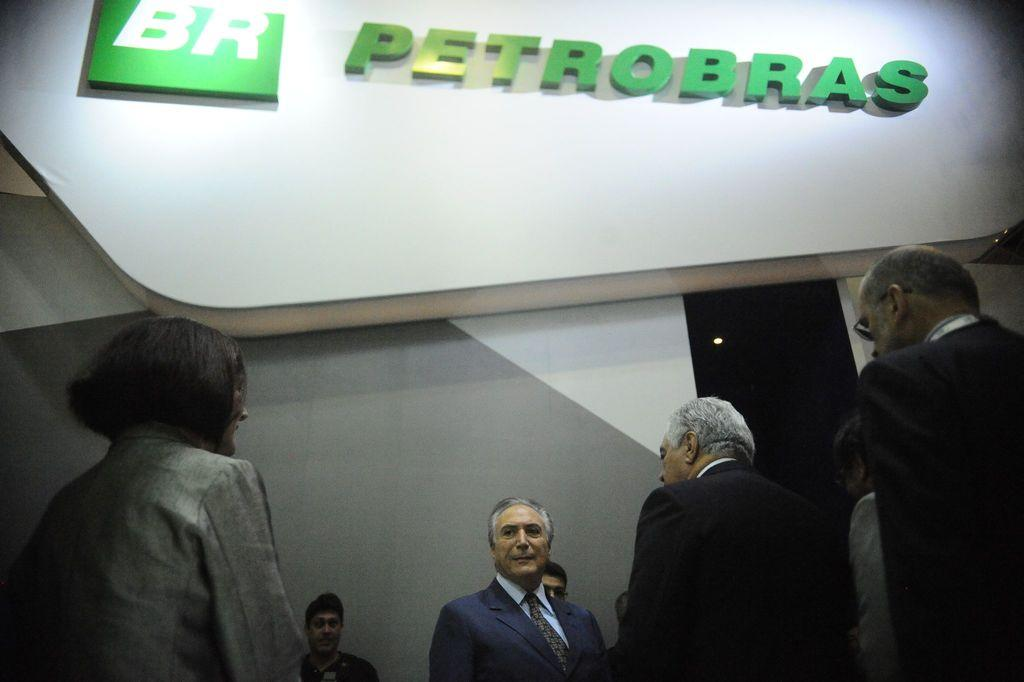How many people are in the image? There is a group of persons in the image, but the exact number cannot be determined from the provided facts. What is behind the persons in the image? There is a wall behind the persons in the image. Can you describe the light in the image? There is a light in the image, but its specific characteristics are not mentioned in the provided facts. What is written on the wall in the image? There is text on the wall in the image. How does the group of persons breathe in the image? The provided facts do not mention anything about the group of persons breathing, so we cannot answer this question based on the information given. 